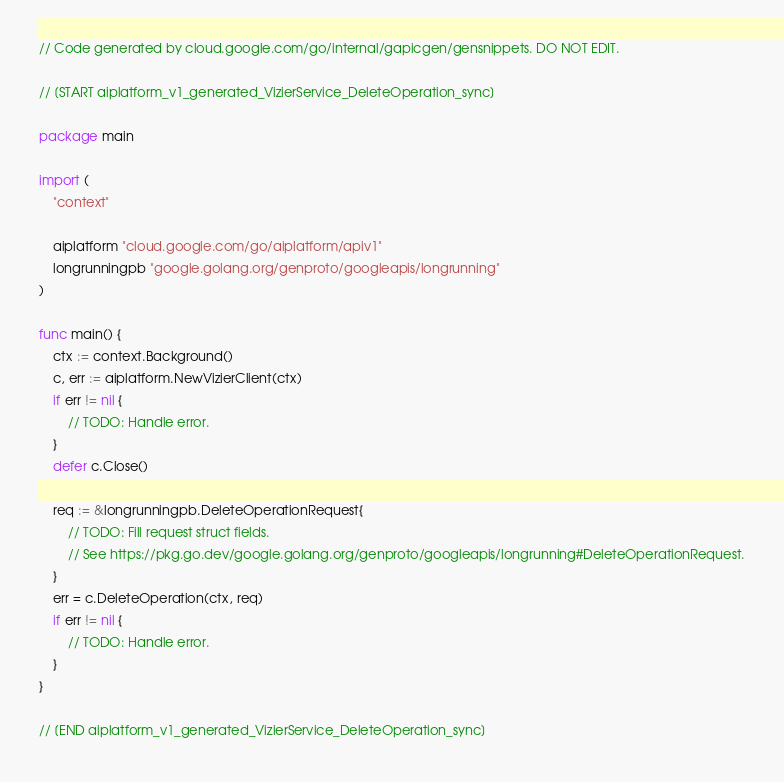<code> <loc_0><loc_0><loc_500><loc_500><_Go_>
// Code generated by cloud.google.com/go/internal/gapicgen/gensnippets. DO NOT EDIT.

// [START aiplatform_v1_generated_VizierService_DeleteOperation_sync]

package main

import (
	"context"

	aiplatform "cloud.google.com/go/aiplatform/apiv1"
	longrunningpb "google.golang.org/genproto/googleapis/longrunning"
)

func main() {
	ctx := context.Background()
	c, err := aiplatform.NewVizierClient(ctx)
	if err != nil {
		// TODO: Handle error.
	}
	defer c.Close()

	req := &longrunningpb.DeleteOperationRequest{
		// TODO: Fill request struct fields.
		// See https://pkg.go.dev/google.golang.org/genproto/googleapis/longrunning#DeleteOperationRequest.
	}
	err = c.DeleteOperation(ctx, req)
	if err != nil {
		// TODO: Handle error.
	}
}

// [END aiplatform_v1_generated_VizierService_DeleteOperation_sync]
</code> 